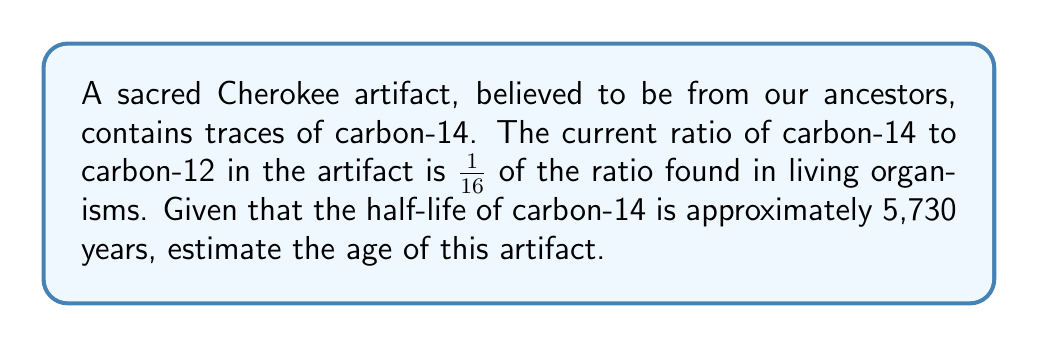Help me with this question. To solve this problem, we'll use the principles of radioactive decay and the given information about carbon-14 dating.

Step 1: Identify the relevant equation
The decay of radioactive isotopes follows an exponential decay law:

$$ N(t) = N_0 \cdot 2^{-t/t_{1/2}} $$

Where:
$N(t)$ is the amount of the isotope at time $t$
$N_0$ is the initial amount
$t$ is the time elapsed
$t_{1/2}$ is the half-life

Step 2: Set up the equation using the given information
We know that the current ratio is 1/16 of the original, so:

$$ \frac{1}{16} = 2^{-t/5730} $$

Step 3: Solve for $t$ using logarithms
Take the natural log of both sides:

$$ \ln(\frac{1}{16}) = \ln(2^{-t/5730}) $$

$$ -\ln(16) = -\frac{t}{5730} \ln(2) $$

$$ \ln(16) = \frac{t}{5730} \ln(2) $$

Now solve for $t$:

$$ t = 5730 \cdot \frac{\ln(16)}{\ln(2)} $$

Step 4: Calculate the result
$$ t = 5730 \cdot \frac{\ln(16)}{\ln(2)} \approx 22,920 \text{ years} $$

Therefore, the estimated age of the artifact is approximately 22,920 years.
Answer: 22,920 years 